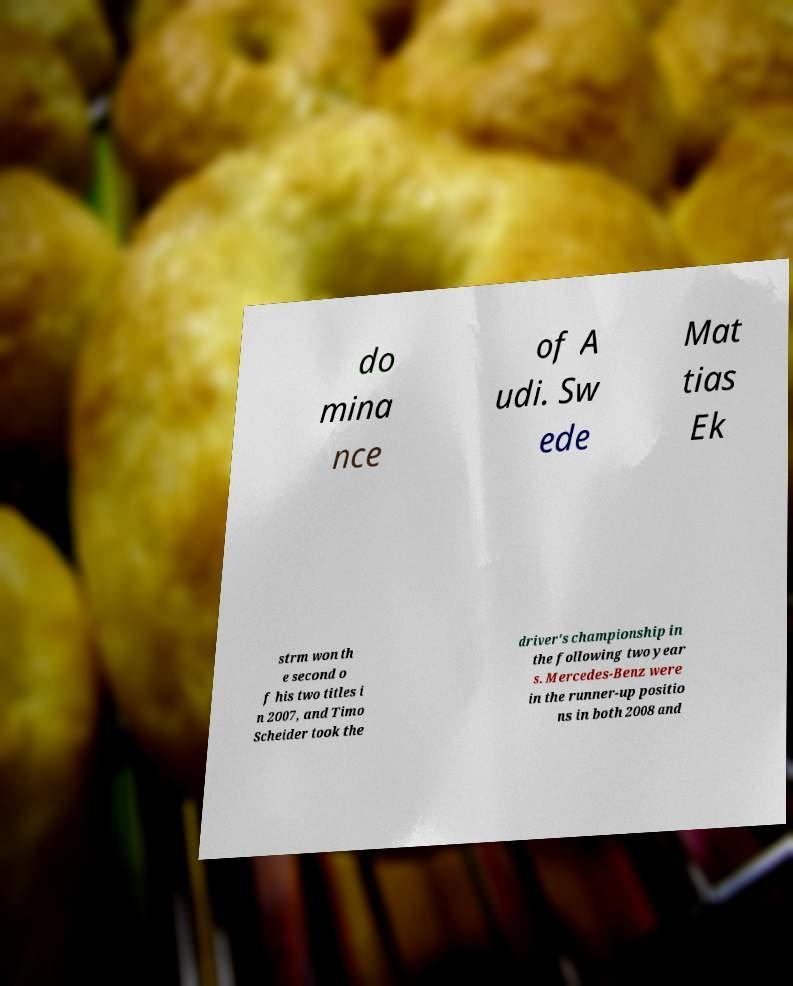Could you assist in decoding the text presented in this image and type it out clearly? do mina nce of A udi. Sw ede Mat tias Ek strm won th e second o f his two titles i n 2007, and Timo Scheider took the driver's championship in the following two year s. Mercedes-Benz were in the runner-up positio ns in both 2008 and 